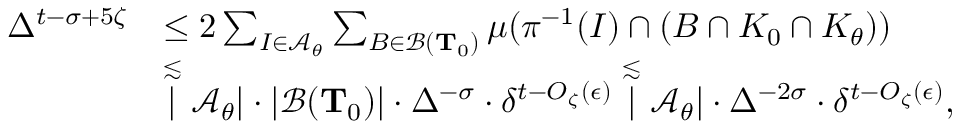<formula> <loc_0><loc_0><loc_500><loc_500>\begin{array} { r l } { \Delta ^ { t - \sigma + 5 \zeta } } & { \leq 2 \sum _ { I \in \mathcal { A } _ { \theta } } \sum _ { B \in \mathcal { B } ( T _ { 0 } ) } \mu ( \pi ^ { - 1 } ( I ) \cap ( B \cap K _ { 0 } \cap K _ { \theta } ) ) } \\ & { \stackrel { \lesssim } | \mathcal { A } _ { \theta } | \cdot | \mathcal { B } ( T _ { 0 } ) | \cdot \Delta ^ { - \sigma } \cdot \delta ^ { t - O _ { \zeta } ( \epsilon ) } \stackrel { \lesssim } | \mathcal { A } _ { \theta } | \cdot \Delta ^ { - 2 \sigma } \cdot \delta ^ { t - O _ { \zeta } ( \epsilon ) } , } \end{array}</formula> 